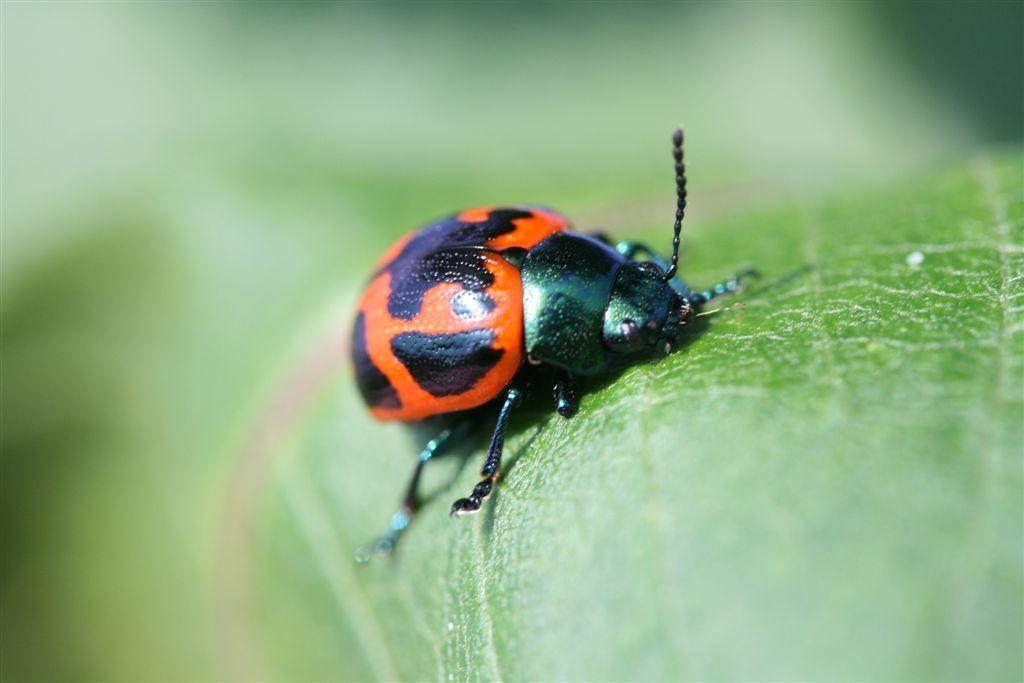Can you describe this image briefly? In this picture we can see a ladybird beetle on the leaf. 